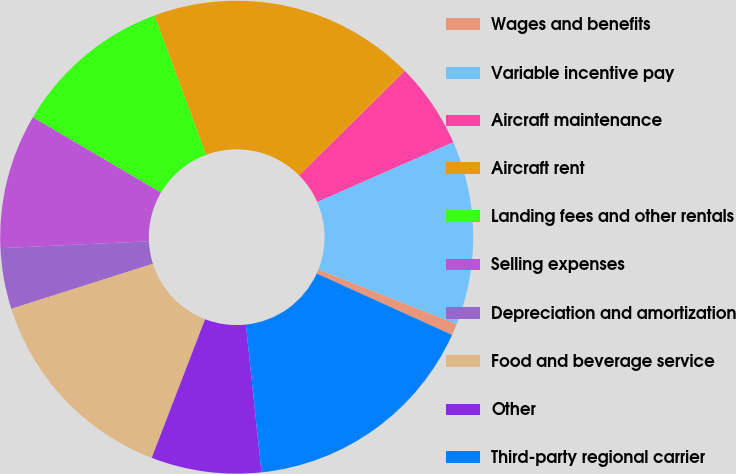Convert chart. <chart><loc_0><loc_0><loc_500><loc_500><pie_chart><fcel>Wages and benefits<fcel>Variable incentive pay<fcel>Aircraft maintenance<fcel>Aircraft rent<fcel>Landing fees and other rentals<fcel>Selling expenses<fcel>Depreciation and amortization<fcel>Food and beverage service<fcel>Other<fcel>Third-party regional carrier<nl><fcel>0.79%<fcel>12.57%<fcel>5.84%<fcel>18.23%<fcel>10.88%<fcel>9.2%<fcel>4.16%<fcel>14.25%<fcel>7.52%<fcel>16.55%<nl></chart> 